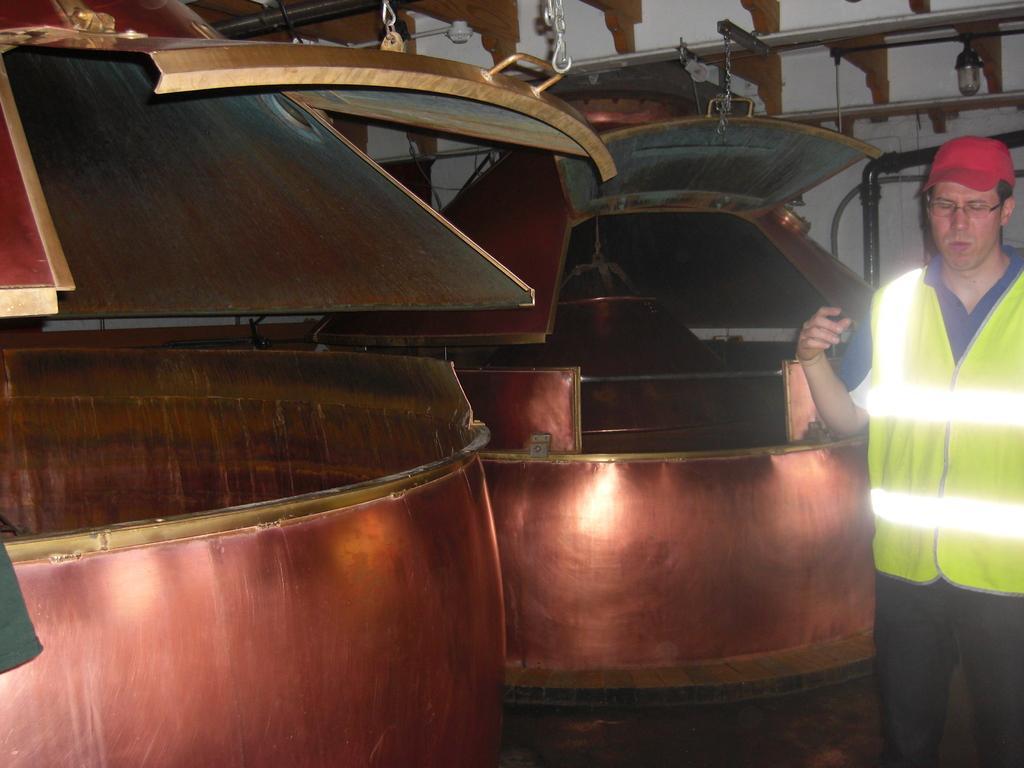Please provide a concise description of this image. In this image there is a man standing. Beside him there are containers. There are hooks attached to the containers. Behind it there is a wall. 